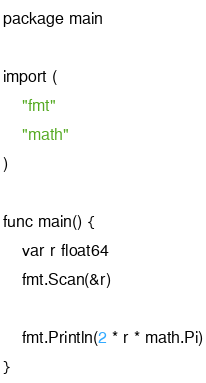<code> <loc_0><loc_0><loc_500><loc_500><_C_>package main

import (
	"fmt"
	"math"
)

func main() {
	var r float64
	fmt.Scan(&r)

	fmt.Println(2 * r * math.Pi)
}
</code> 